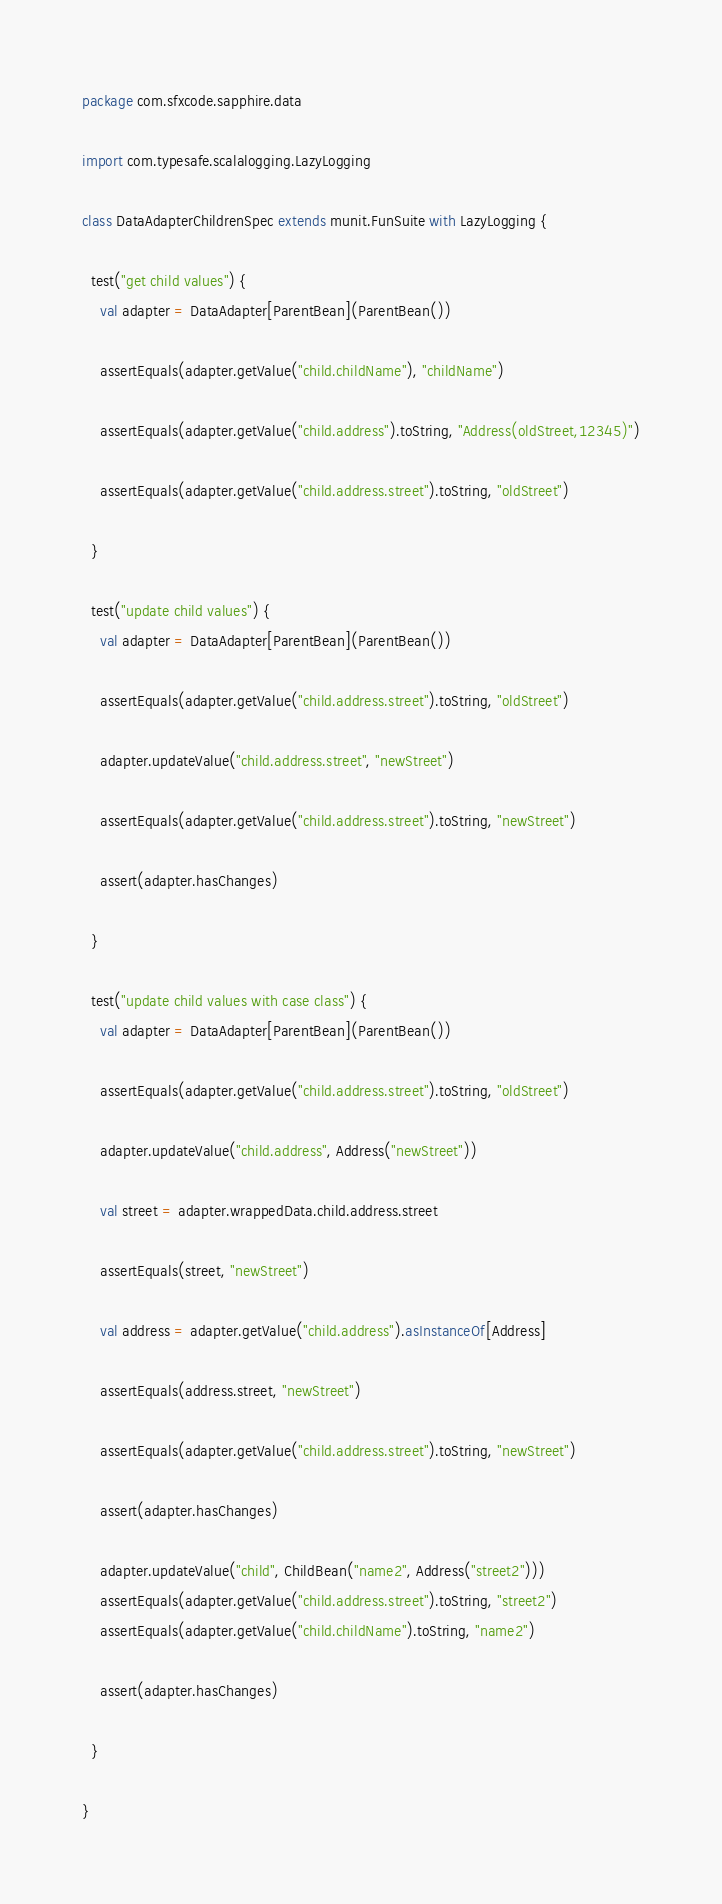<code> <loc_0><loc_0><loc_500><loc_500><_Scala_>package com.sfxcode.sapphire.data

import com.typesafe.scalalogging.LazyLogging

class DataAdapterChildrenSpec extends munit.FunSuite with LazyLogging {

  test("get child values") {
    val adapter = DataAdapter[ParentBean](ParentBean())

    assertEquals(adapter.getValue("child.childName"), "childName")

    assertEquals(adapter.getValue("child.address").toString, "Address(oldStreet,12345)")

    assertEquals(adapter.getValue("child.address.street").toString, "oldStreet")

  }

  test("update child values") {
    val adapter = DataAdapter[ParentBean](ParentBean())

    assertEquals(adapter.getValue("child.address.street").toString, "oldStreet")

    adapter.updateValue("child.address.street", "newStreet")

    assertEquals(adapter.getValue("child.address.street").toString, "newStreet")

    assert(adapter.hasChanges)

  }

  test("update child values with case class") {
    val adapter = DataAdapter[ParentBean](ParentBean())

    assertEquals(adapter.getValue("child.address.street").toString, "oldStreet")

    adapter.updateValue("child.address", Address("newStreet"))

    val street = adapter.wrappedData.child.address.street

    assertEquals(street, "newStreet")

    val address = adapter.getValue("child.address").asInstanceOf[Address]

    assertEquals(address.street, "newStreet")

    assertEquals(adapter.getValue("child.address.street").toString, "newStreet")

    assert(adapter.hasChanges)

    adapter.updateValue("child", ChildBean("name2", Address("street2")))
    assertEquals(adapter.getValue("child.address.street").toString, "street2")
    assertEquals(adapter.getValue("child.childName").toString, "name2")

    assert(adapter.hasChanges)

  }

}
</code> 